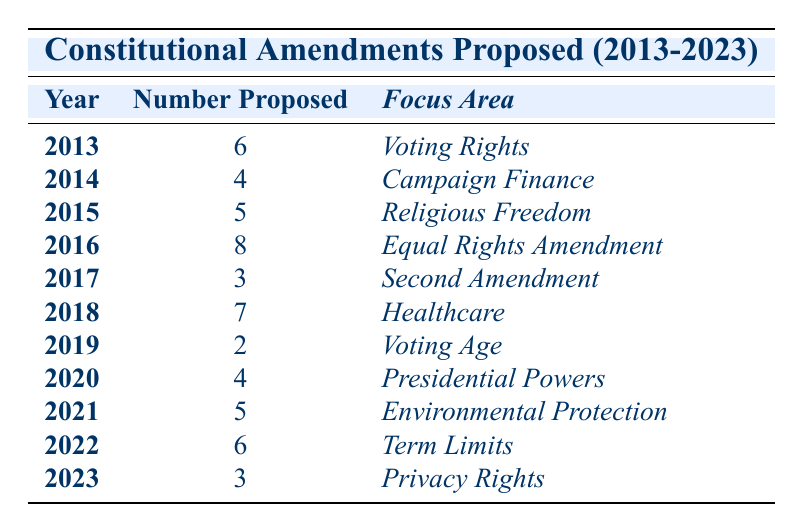What year had the highest number of proposed amendments? In the table, the highest number of proposed amendments is 8, which occurred in 2016.
Answer: 2016 How many amendments were proposed in total from 2013 to 2023? To find the total, sum the number of amendments proposed each year: 6 + 4 + 5 + 8 + 3 + 7 + 2 + 4 + 5 + 6 + 3 = 63.
Answer: 63 Were more amendments proposed in odd years than in even years? Count the amendments in odd years: 2013 (6), 2015 (5), 2017 (3), 2019 (2), 2021 (5), 2023 (3) = 24. Count the amendments in even years: 2014 (4), 2016 (8), 2018 (7), 2020 (4), 2022 (6) = 29. Since 24 < 29, the answer is no.
Answer: No What is the average number of amendments proposed per year? To find the average, divide the total number of amendments (63) by the number of years (11): 63 ÷ 11 = 5.73.
Answer: Approximately 5.73 How many amendments focusing on Healthcare were proposed? The table shows that 7 amendments were proposed in 2018, focusing on Healthcare.
Answer: 7 In which year was the fewest amendments proposed, and how many were proposed? Looking at the table, the year with the fewest proposed amendments is 2019 with 2 proposed.
Answer: 2019, 2 Did the number of proposed amendments increase from 2015 to 2016? The number of amendments proposed in 2015 is 5, and in 2016, it is 8. Since 8 > 5, the number did increase.
Answer: Yes Which focus area had the second highest number of proposed amendments? The two highest numbers are 8 (Equal Rights Amendment) and 7 (Healthcare). Thus, the second highest is 7 proposed for Healthcare.
Answer: Healthcare In which year was there an equal number of proposed amendments to those proposed in 2014? In 2014, 4 amendments were proposed. The years with the same amount are 2020 and 2014, both with 4 proposed.
Answer: 2014, 2020 